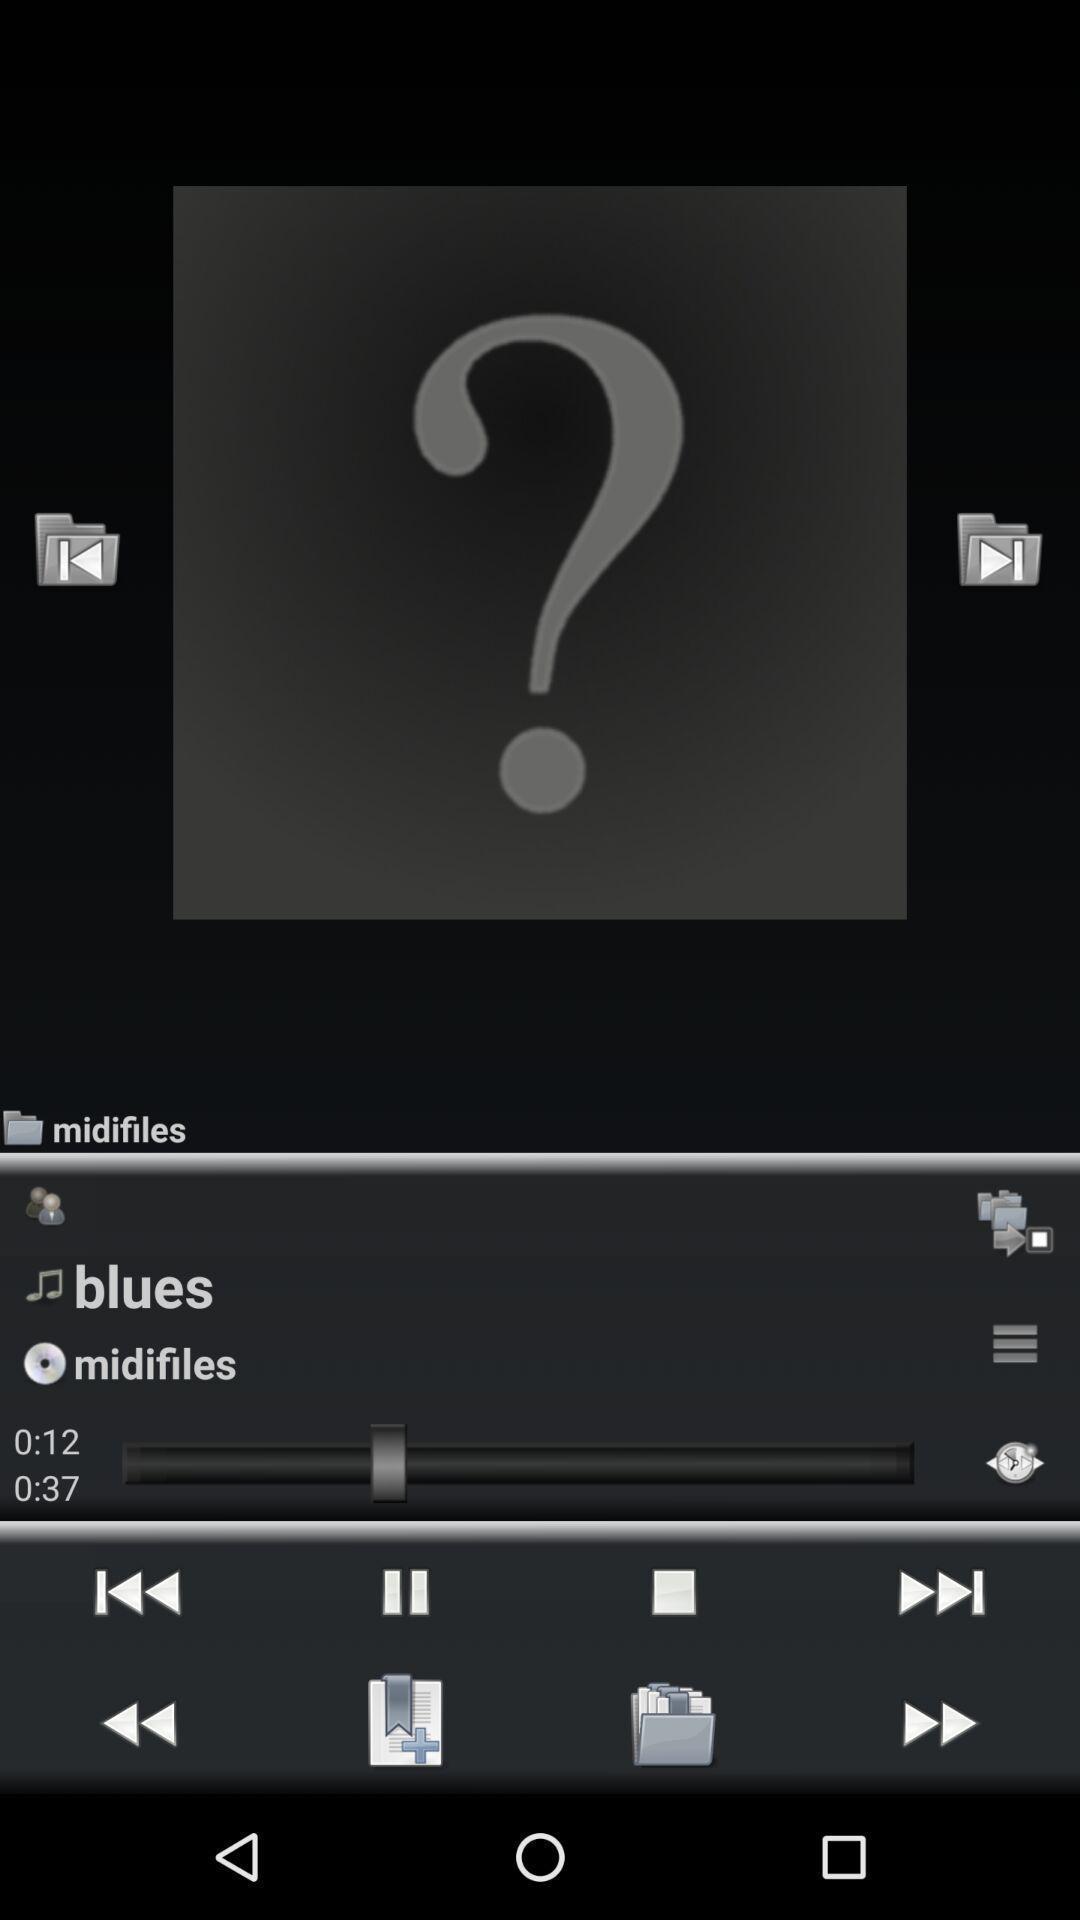What can you discern from this picture? Page displaying few options in a music app. 